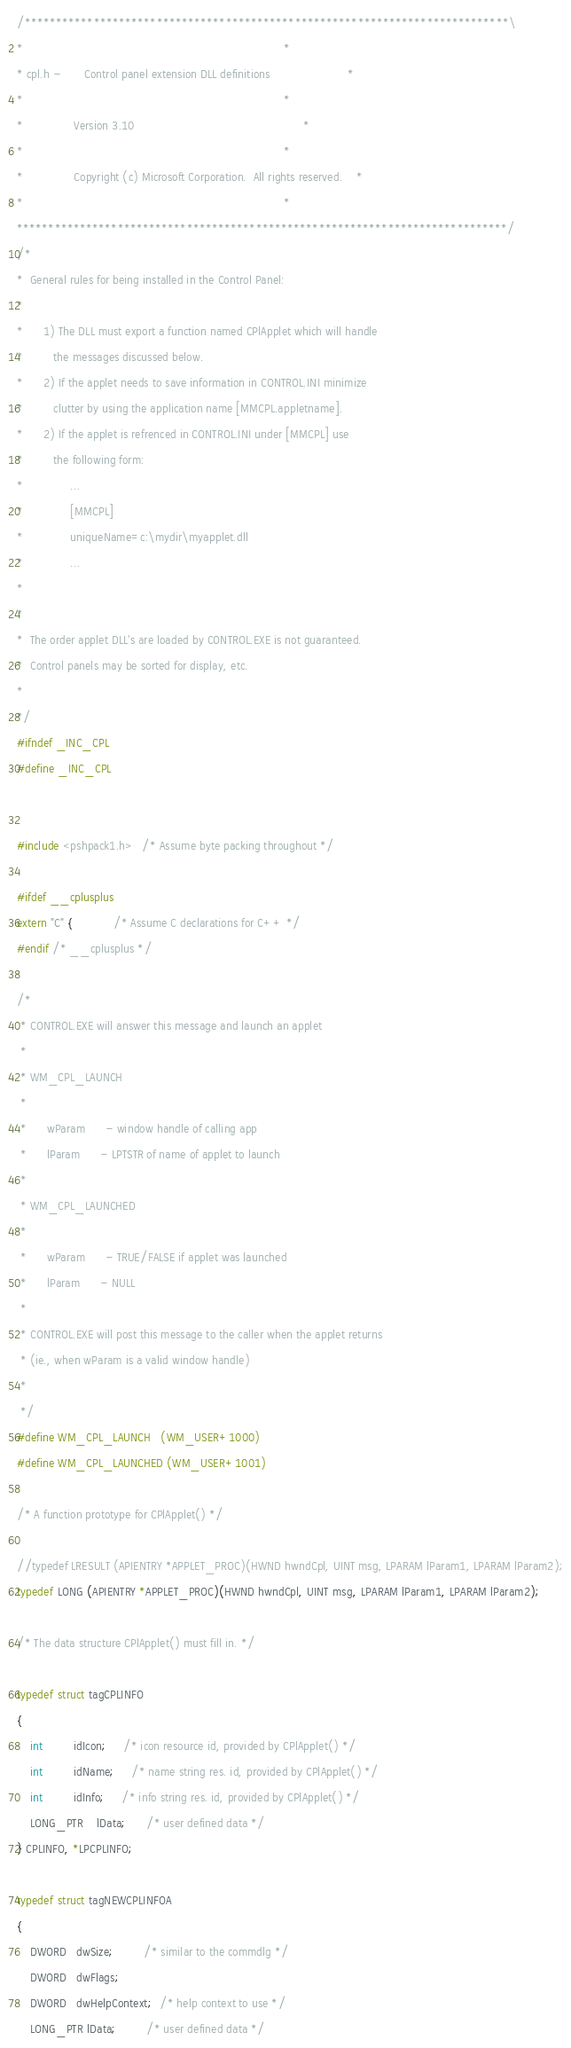<code> <loc_0><loc_0><loc_500><loc_500><_C_>
/*****************************************************************************\
*                                                                             *
* cpl.h -       Control panel extension DLL definitions                       *
*                                                                             *
*               Version 3.10                                                  *
*                                                                             *
*               Copyright (c) Microsoft Corporation.  All rights reserved.    *
*                                                                             *
******************************************************************************/
/*
*  General rules for being installed in the Control Panel:
*
*      1) The DLL must export a function named CPlApplet which will handle
*         the messages discussed below.
*      2) If the applet needs to save information in CONTROL.INI minimize
*         clutter by using the application name [MMCPL.appletname].
*      2) If the applet is refrenced in CONTROL.INI under [MMCPL] use
*         the following form:
*              ...
*              [MMCPL]
*              uniqueName=c:\mydir\myapplet.dll
*              ...
*
*
*  The order applet DLL's are loaded by CONTROL.EXE is not guaranteed.
*  Control panels may be sorted for display, etc.
*
*/
#ifndef _INC_CPL
#define _INC_CPL 


#include <pshpack1.h>   /* Assume byte packing throughout */

#ifdef __cplusplus
extern "C" {            /* Assume C declarations for C++ */
#endif /* __cplusplus */

/*
 * CONTROL.EXE will answer this message and launch an applet
 *
 * WM_CPL_LAUNCH
 *
 *      wParam      - window handle of calling app
 *      lParam      - LPTSTR of name of applet to launch
 *
 * WM_CPL_LAUNCHED
 *
 *      wParam      - TRUE/FALSE if applet was launched
 *      lParam      - NULL
 *
 * CONTROL.EXE will post this message to the caller when the applet returns
 * (ie., when wParam is a valid window handle)
 *
 */
#define WM_CPL_LAUNCH   (WM_USER+1000)
#define WM_CPL_LAUNCHED (WM_USER+1001)

/* A function prototype for CPlApplet() */

//typedef LRESULT (APIENTRY *APPLET_PROC)(HWND hwndCpl, UINT msg, LPARAM lParam1, LPARAM lParam2);
typedef LONG (APIENTRY *APPLET_PROC)(HWND hwndCpl, UINT msg, LPARAM lParam1, LPARAM lParam2);

/* The data structure CPlApplet() must fill in. */

typedef struct tagCPLINFO
{
    int         idIcon;     /* icon resource id, provided by CPlApplet() */
    int         idName;     /* name string res. id, provided by CPlApplet() */
    int         idInfo;     /* info string res. id, provided by CPlApplet() */
    LONG_PTR    lData;      /* user defined data */
} CPLINFO, *LPCPLINFO;

typedef struct tagNEWCPLINFOA
{
    DWORD   dwSize;         /* similar to the commdlg */
    DWORD   dwFlags;
    DWORD   dwHelpContext;  /* help context to use */
    LONG_PTR lData;         /* user defined data */</code> 